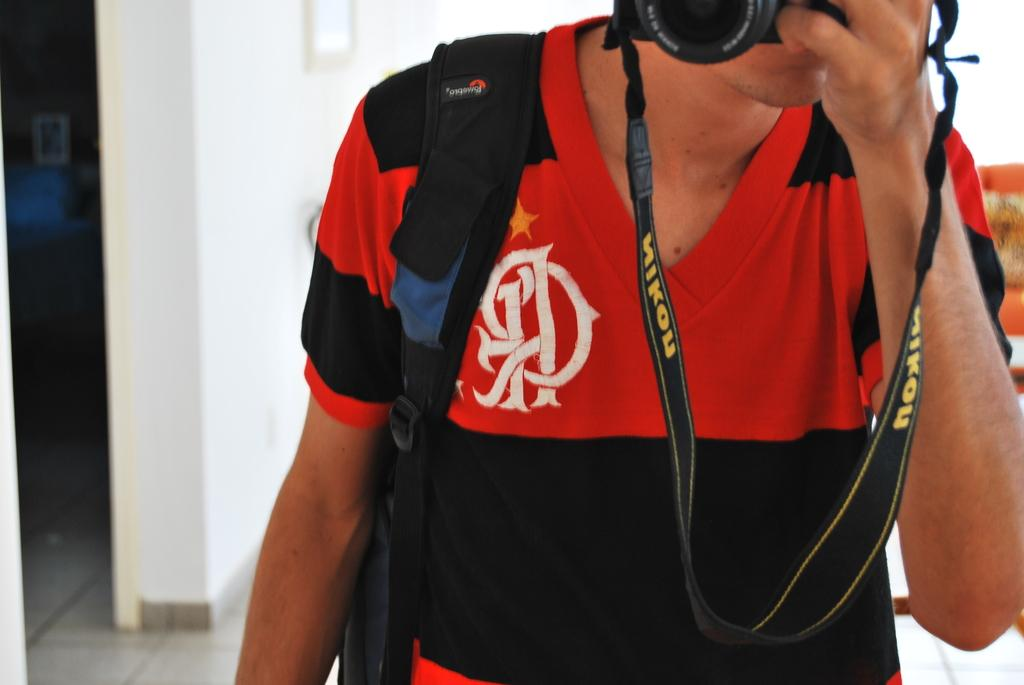<image>
Share a concise interpretation of the image provided. A man is holding a camera and the strap says Nikon. 